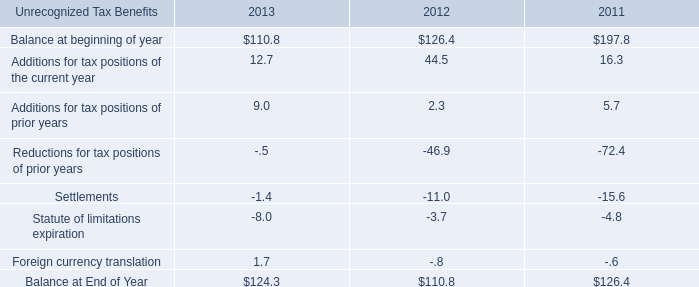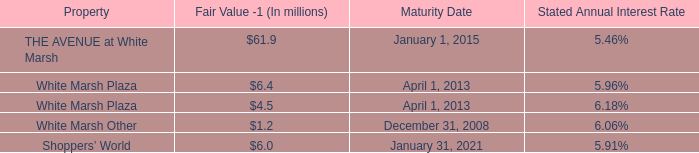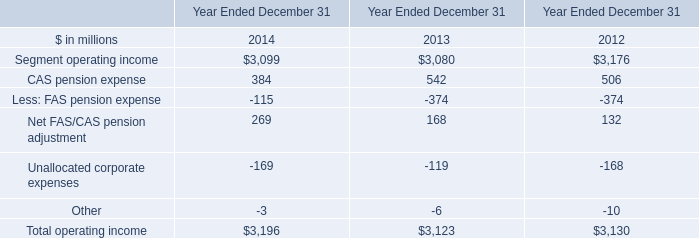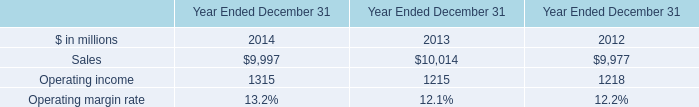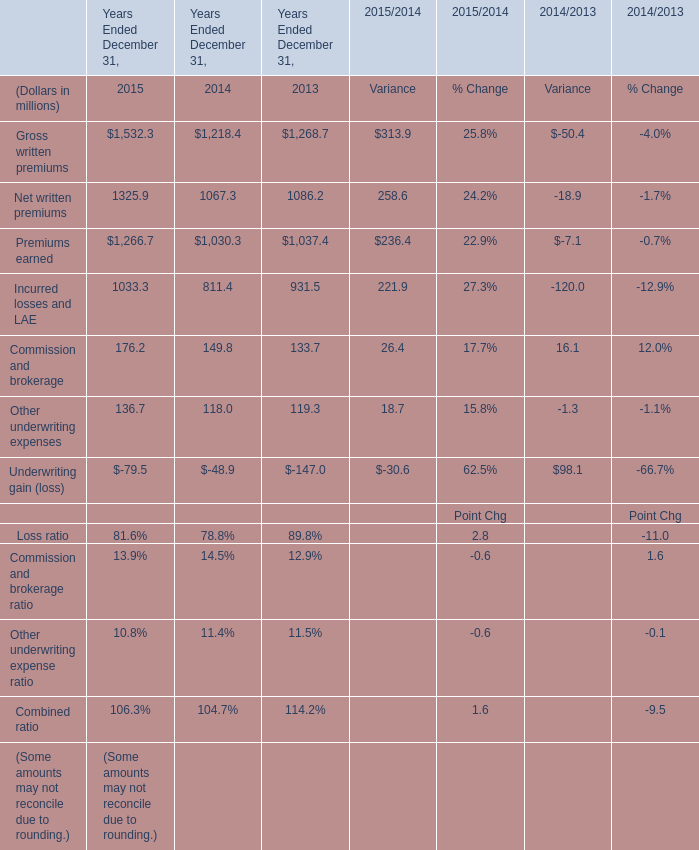what's the total amount of Sales of Year Ended December 31 2012, Net written premiums of Years Ended December 31, 2015, and Segment operating income of Year Ended December 31 2013 ? 
Computations: ((9977.0 + 1325.9) + 3080.0)
Answer: 14382.9. 